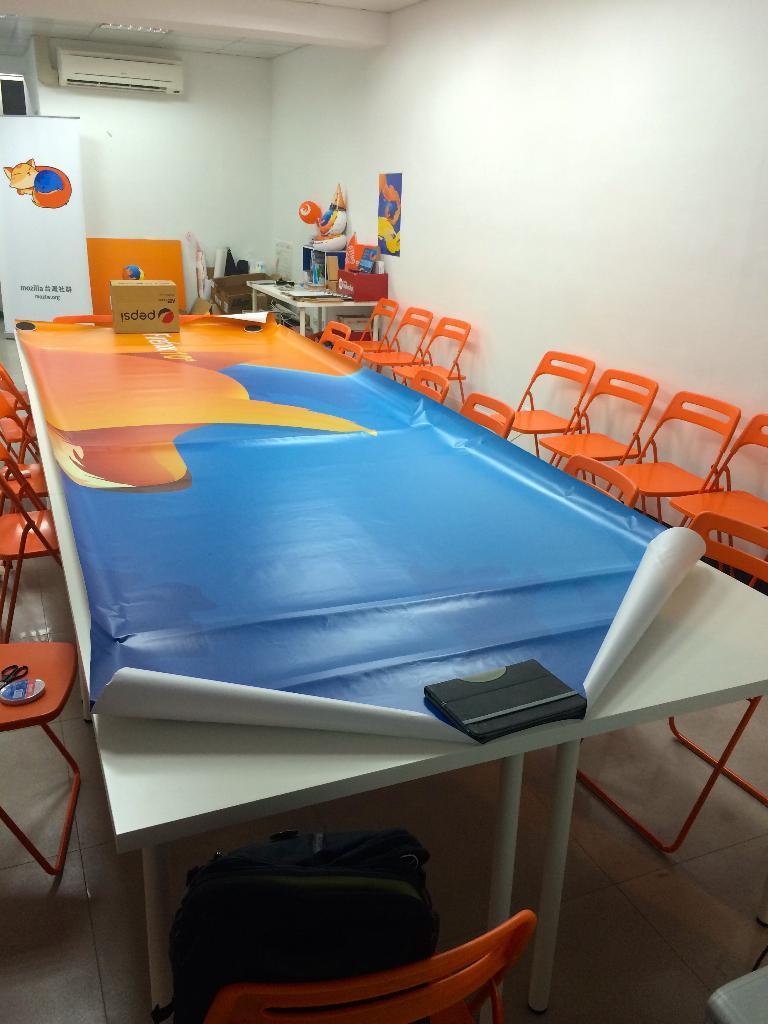Please provide a concise description of this image. In this image we can see chairs, table, cardboard cartons, advertisement boards, objects arranged on the table and an air conditioner. 